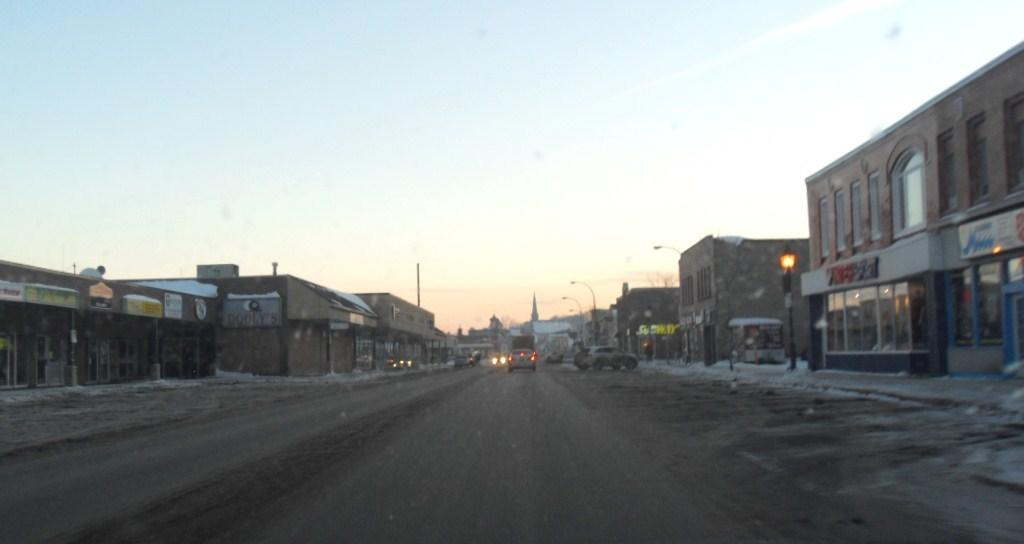What type of structures can be seen in the image? There are buildings in the image. What signs are visible in the image? There are name boards in the image. What type of vertical structures are present in the image? There are street poles in the image. What type of lighting is present in the image? There are street lights in the image. What type of transportation is present on the road in the image? Motor vehicles are present on the road in the image. What part of the natural environment is visible in the image? The sky is visible in the image. Can you hear the bell ringing in the image? There is no bell present in the image, so it cannot be heard. Are there any mountains visible in the image? There are no mountains present in the image; it features buildings, name boards, street poles, street lights, motor vehicles, and the sky. 